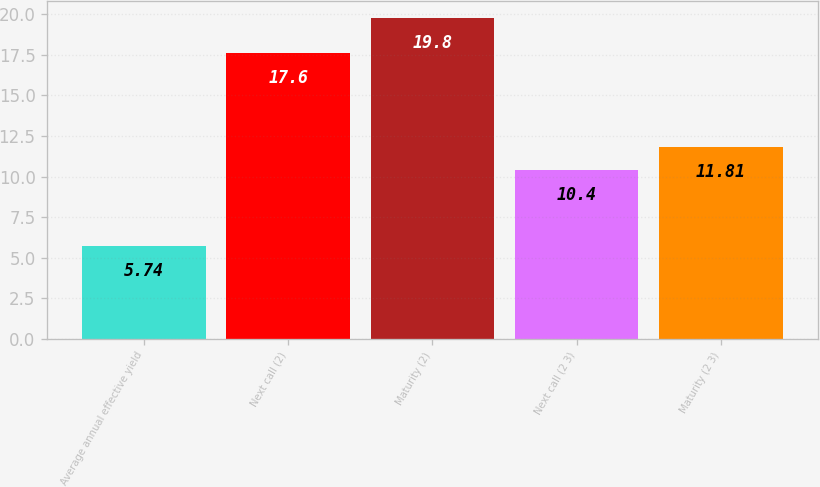Convert chart to OTSL. <chart><loc_0><loc_0><loc_500><loc_500><bar_chart><fcel>Average annual effective yield<fcel>Next call (2)<fcel>Maturity (2)<fcel>Next call (2 3)<fcel>Maturity (2 3)<nl><fcel>5.74<fcel>17.6<fcel>19.8<fcel>10.4<fcel>11.81<nl></chart> 